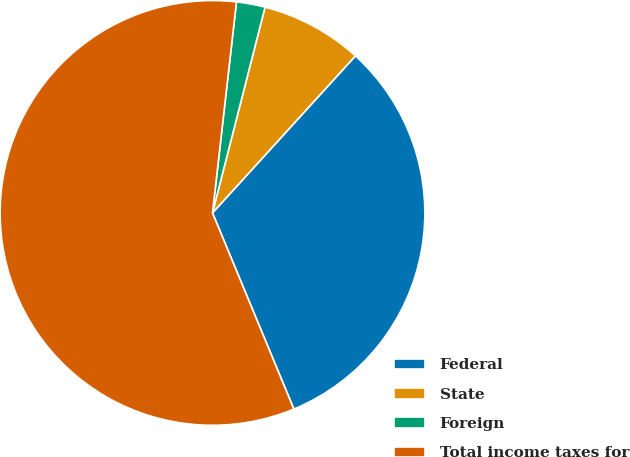<chart> <loc_0><loc_0><loc_500><loc_500><pie_chart><fcel>Federal<fcel>State<fcel>Foreign<fcel>Total income taxes for<nl><fcel>31.99%<fcel>7.77%<fcel>2.18%<fcel>58.06%<nl></chart> 